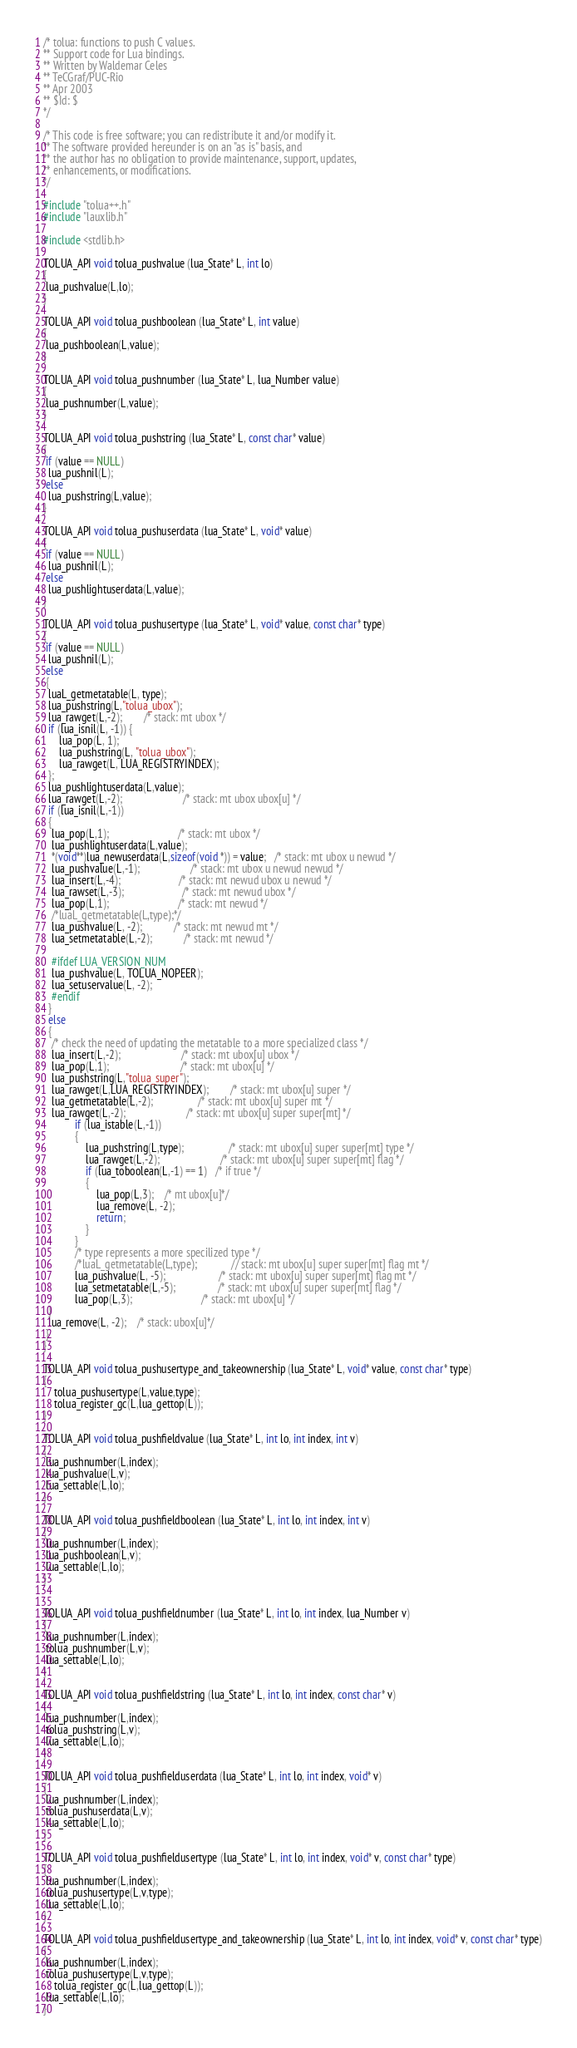Convert code to text. <code><loc_0><loc_0><loc_500><loc_500><_C_>/* tolua: functions to push C values.
** Support code for Lua bindings.
** Written by Waldemar Celes
** TeCGraf/PUC-Rio
** Apr 2003
** $Id: $
*/

/* This code is free software; you can redistribute it and/or modify it.
** The software provided hereunder is on an "as is" basis, and
** the author has no obligation to provide maintenance, support, updates,
** enhancements, or modifications.
*/

#include "tolua++.h"
#include "lauxlib.h"

#include <stdlib.h>

TOLUA_API void tolua_pushvalue (lua_State* L, int lo)
{
 lua_pushvalue(L,lo);
}

TOLUA_API void tolua_pushboolean (lua_State* L, int value)
{
 lua_pushboolean(L,value);
}

TOLUA_API void tolua_pushnumber (lua_State* L, lua_Number value)
{
 lua_pushnumber(L,value);
}

TOLUA_API void tolua_pushstring (lua_State* L, const char* value)
{
 if (value == NULL)
  lua_pushnil(L);
 else
  lua_pushstring(L,value);
}

TOLUA_API void tolua_pushuserdata (lua_State* L, void* value)
{
 if (value == NULL)
  lua_pushnil(L);
 else
  lua_pushlightuserdata(L,value);
}

TOLUA_API void tolua_pushusertype (lua_State* L, void* value, const char* type)
{
 if (value == NULL)
  lua_pushnil(L);
 else
 {
  luaL_getmetatable(L, type);
  lua_pushstring(L,"tolua_ubox");
  lua_rawget(L,-2);        /* stack: mt ubox */
  if (lua_isnil(L, -1)) {
	  lua_pop(L, 1);
	  lua_pushstring(L, "tolua_ubox");
	  lua_rawget(L, LUA_REGISTRYINDEX);
  };
  lua_pushlightuserdata(L,value);
  lua_rawget(L,-2);                       /* stack: mt ubox ubox[u] */
  if (lua_isnil(L,-1))
  {
   lua_pop(L,1);                          /* stack: mt ubox */
   lua_pushlightuserdata(L,value);
   *(void**)lua_newuserdata(L,sizeof(void *)) = value;   /* stack: mt ubox u newud */
   lua_pushvalue(L,-1);                   /* stack: mt ubox u newud newud */
   lua_insert(L,-4);                      /* stack: mt newud ubox u newud */
   lua_rawset(L,-3);                      /* stack: mt newud ubox */
   lua_pop(L,1);                          /* stack: mt newud */
   /*luaL_getmetatable(L,type);*/
   lua_pushvalue(L, -2);			/* stack: mt newud mt */
   lua_setmetatable(L,-2);			/* stack: mt newud */

   #ifdef LUA_VERSION_NUM
   lua_pushvalue(L, TOLUA_NOPEER);
   lua_setuservalue(L, -2);
   #endif
  }
  else
  {
   /* check the need of updating the metatable to a more specialized class */
   lua_insert(L,-2);                       /* stack: mt ubox[u] ubox */
   lua_pop(L,1);                           /* stack: mt ubox[u] */
   lua_pushstring(L,"tolua_super");
   lua_rawget(L,LUA_REGISTRYINDEX);        /* stack: mt ubox[u] super */
   lua_getmetatable(L,-2);                 /* stack: mt ubox[u] super mt */
   lua_rawget(L,-2);                       /* stack: mt ubox[u] super super[mt] */
			if (lua_istable(L,-1))
			{
				lua_pushstring(L,type);                 /* stack: mt ubox[u] super super[mt] type */
				lua_rawget(L,-2);                       /* stack: mt ubox[u] super super[mt] flag */
				if (lua_toboolean(L,-1) == 1)   /* if true */
				{
					lua_pop(L,3);	/* mt ubox[u]*/
					lua_remove(L, -2);
					return;
				}
			}
			/* type represents a more specilized type */
			/*luaL_getmetatable(L,type);             // stack: mt ubox[u] super super[mt] flag mt */
			lua_pushvalue(L, -5);					/* stack: mt ubox[u] super super[mt] flag mt */
			lua_setmetatable(L,-5);                /* stack: mt ubox[u] super super[mt] flag */
			lua_pop(L,3);                          /* stack: mt ubox[u] */
  }
  lua_remove(L, -2);	/* stack: ubox[u]*/
 }
}

TOLUA_API void tolua_pushusertype_and_takeownership (lua_State* L, void* value, const char* type)
{
	tolua_pushusertype(L,value,type);
	tolua_register_gc(L,lua_gettop(L));
}

TOLUA_API void tolua_pushfieldvalue (lua_State* L, int lo, int index, int v)
{
 lua_pushnumber(L,index);
 lua_pushvalue(L,v);
 lua_settable(L,lo);
}

TOLUA_API void tolua_pushfieldboolean (lua_State* L, int lo, int index, int v)
{
 lua_pushnumber(L,index);
 lua_pushboolean(L,v);
 lua_settable(L,lo);
}


TOLUA_API void tolua_pushfieldnumber (lua_State* L, int lo, int index, lua_Number v)
{
 lua_pushnumber(L,index);
 tolua_pushnumber(L,v);
 lua_settable(L,lo);
}

TOLUA_API void tolua_pushfieldstring (lua_State* L, int lo, int index, const char* v)
{
 lua_pushnumber(L,index);
 tolua_pushstring(L,v);
 lua_settable(L,lo);
}

TOLUA_API void tolua_pushfielduserdata (lua_State* L, int lo, int index, void* v)
{
 lua_pushnumber(L,index);
 tolua_pushuserdata(L,v);
 lua_settable(L,lo);
}

TOLUA_API void tolua_pushfieldusertype (lua_State* L, int lo, int index, void* v, const char* type)
{
 lua_pushnumber(L,index);
 tolua_pushusertype(L,v,type);
 lua_settable(L,lo);
}

TOLUA_API void tolua_pushfieldusertype_and_takeownership (lua_State* L, int lo, int index, void* v, const char* type)
{
 lua_pushnumber(L,index);
 tolua_pushusertype(L,v,type);
	tolua_register_gc(L,lua_gettop(L));
 lua_settable(L,lo);
}

</code> 